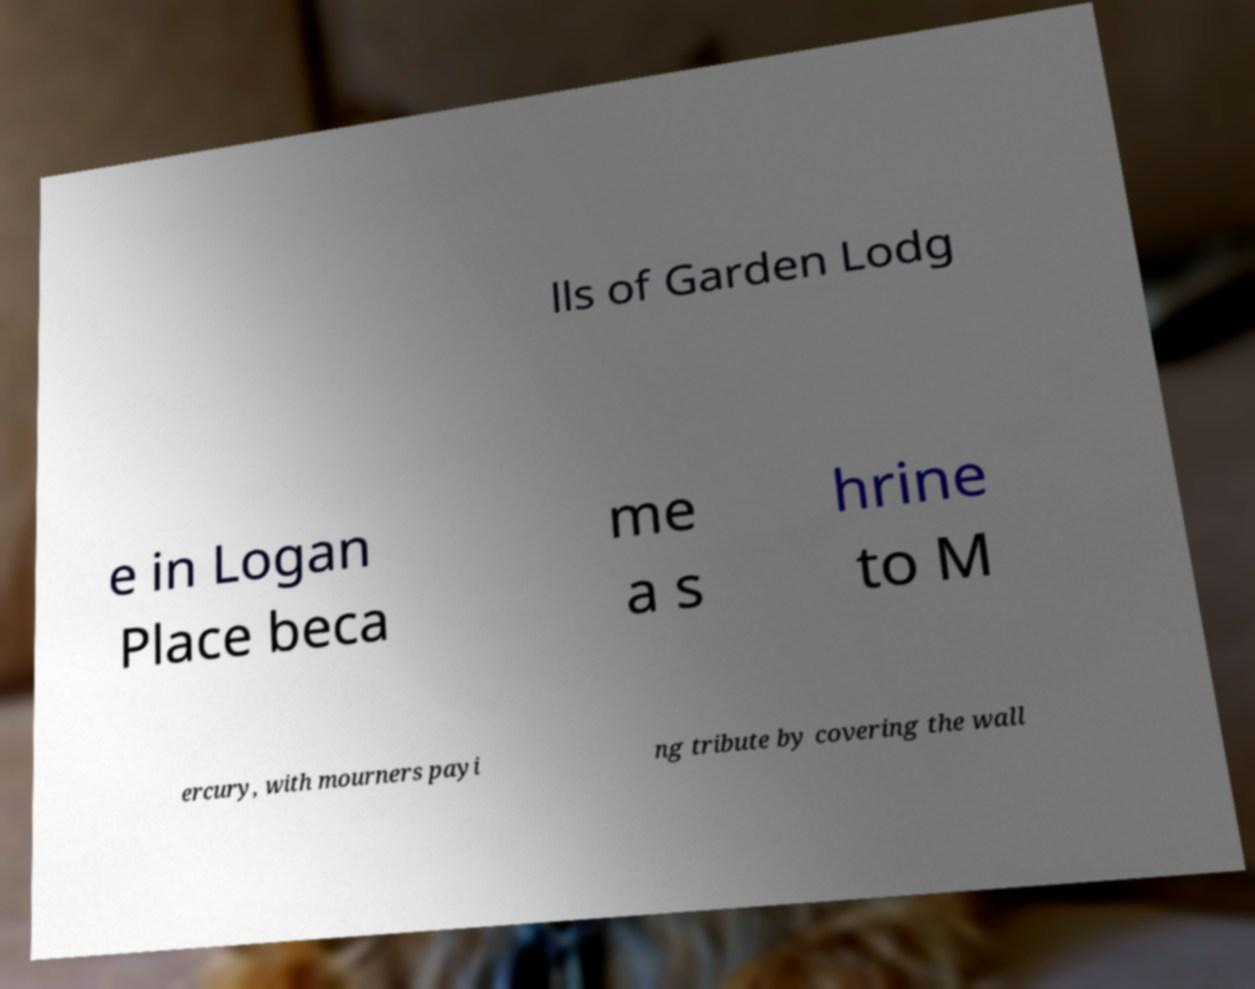Can you read and provide the text displayed in the image?This photo seems to have some interesting text. Can you extract and type it out for me? lls of Garden Lodg e in Logan Place beca me a s hrine to M ercury, with mourners payi ng tribute by covering the wall 